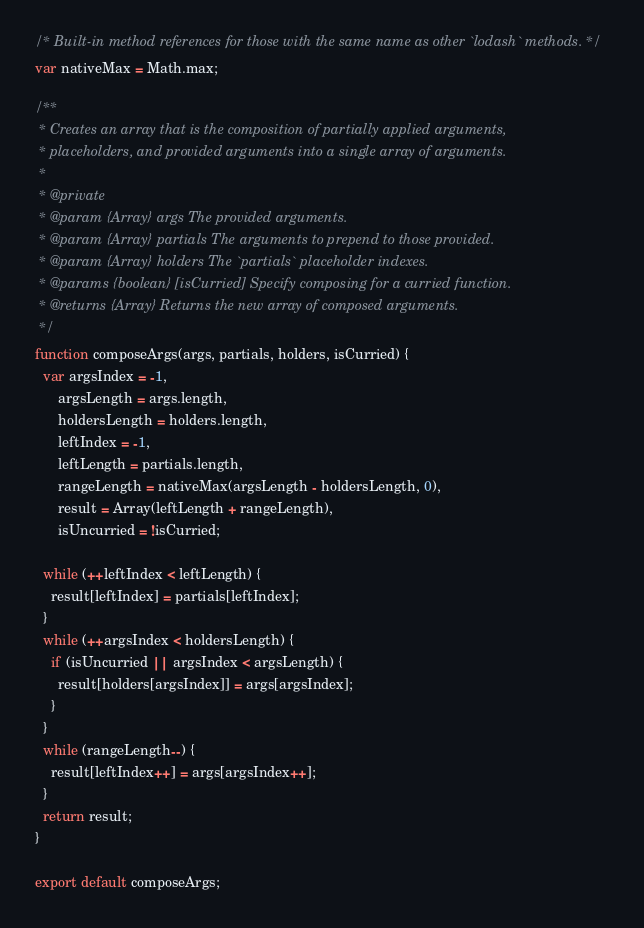Convert code to text. <code><loc_0><loc_0><loc_500><loc_500><_JavaScript_>/* Built-in method references for those with the same name as other `lodash` methods. */
var nativeMax = Math.max;

/**
 * Creates an array that is the composition of partially applied arguments,
 * placeholders, and provided arguments into a single array of arguments.
 *
 * @private
 * @param {Array} args The provided arguments.
 * @param {Array} partials The arguments to prepend to those provided.
 * @param {Array} holders The `partials` placeholder indexes.
 * @params {boolean} [isCurried] Specify composing for a curried function.
 * @returns {Array} Returns the new array of composed arguments.
 */
function composeArgs(args, partials, holders, isCurried) {
  var argsIndex = -1,
      argsLength = args.length,
      holdersLength = holders.length,
      leftIndex = -1,
      leftLength = partials.length,
      rangeLength = nativeMax(argsLength - holdersLength, 0),
      result = Array(leftLength + rangeLength),
      isUncurried = !isCurried;

  while (++leftIndex < leftLength) {
    result[leftIndex] = partials[leftIndex];
  }
  while (++argsIndex < holdersLength) {
    if (isUncurried || argsIndex < argsLength) {
      result[holders[argsIndex]] = args[argsIndex];
    }
  }
  while (rangeLength--) {
    result[leftIndex++] = args[argsIndex++];
  }
  return result;
}

export default composeArgs;
</code> 